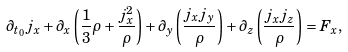Convert formula to latex. <formula><loc_0><loc_0><loc_500><loc_500>\partial _ { t _ { 0 } } j _ { x } + \partial _ { x } \left ( \frac { 1 } { 3 } \rho + \frac { j _ { x } ^ { 2 } } { \rho } \right ) + \partial _ { y } \left ( \frac { j _ { x } j _ { y } } { \rho } \right ) + \partial _ { z } \left ( \frac { j _ { x } j _ { z } } { \rho } \right ) = F _ { x } ,</formula> 